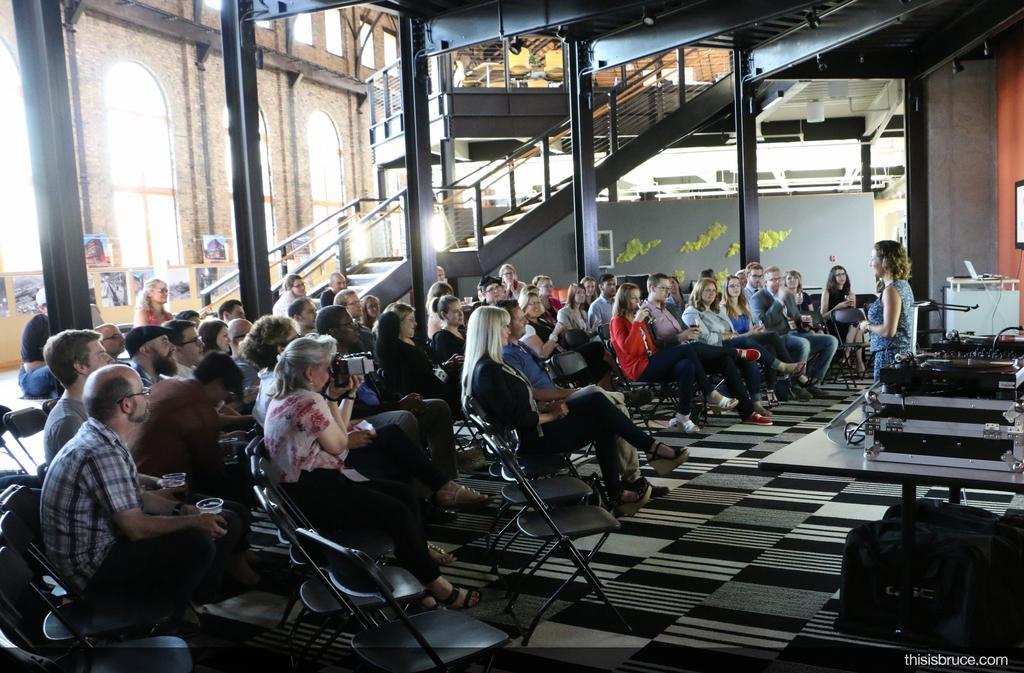In one or two sentences, can you explain what this image depicts? In this image I can see a group of people sitting in chairs facing towards the right. I can see a person standing in front of them and facing towards the left. I can see some metal devices behind her. I can see a metal construction with some stairs and poles behind the people sitting. 